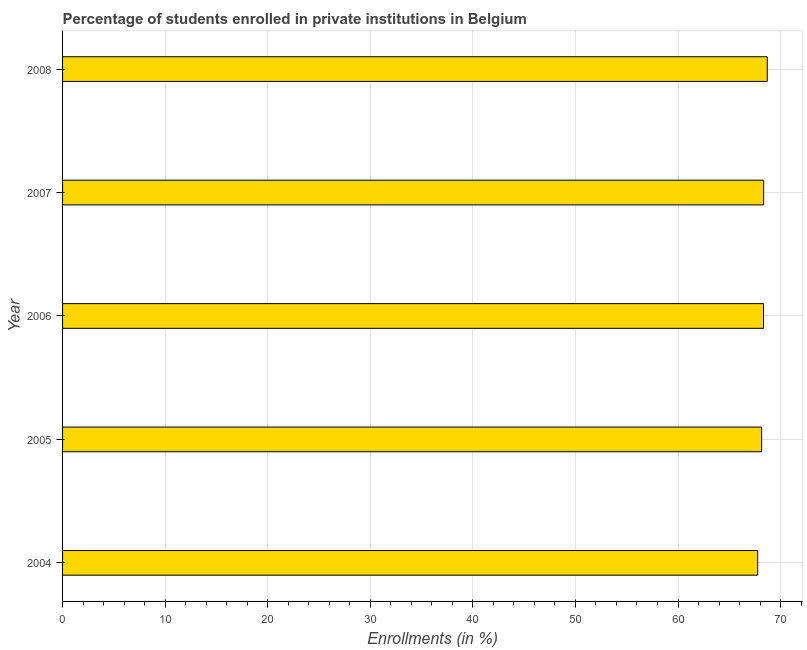Does the graph contain any zero values?
Make the answer very short. No. What is the title of the graph?
Make the answer very short. Percentage of students enrolled in private institutions in Belgium. What is the label or title of the X-axis?
Provide a short and direct response. Enrollments (in %). What is the label or title of the Y-axis?
Provide a succinct answer. Year. What is the enrollments in private institutions in 2004?
Offer a very short reply. 67.77. Across all years, what is the maximum enrollments in private institutions?
Your response must be concise. 68.7. Across all years, what is the minimum enrollments in private institutions?
Offer a terse response. 67.77. In which year was the enrollments in private institutions maximum?
Provide a short and direct response. 2008. What is the sum of the enrollments in private institutions?
Provide a short and direct response. 341.3. What is the difference between the enrollments in private institutions in 2004 and 2007?
Your answer should be very brief. -0.58. What is the average enrollments in private institutions per year?
Give a very brief answer. 68.26. What is the median enrollments in private institutions?
Ensure brevity in your answer.  68.33. Do a majority of the years between 2008 and 2006 (inclusive) have enrollments in private institutions greater than 52 %?
Keep it short and to the point. Yes. What is the difference between the highest and the second highest enrollments in private institutions?
Offer a very short reply. 0.35. Is the sum of the enrollments in private institutions in 2004 and 2006 greater than the maximum enrollments in private institutions across all years?
Provide a succinct answer. Yes. How many years are there in the graph?
Ensure brevity in your answer.  5. What is the Enrollments (in %) in 2004?
Offer a terse response. 67.77. What is the Enrollments (in %) in 2005?
Keep it short and to the point. 68.15. What is the Enrollments (in %) in 2006?
Give a very brief answer. 68.33. What is the Enrollments (in %) of 2007?
Make the answer very short. 68.35. What is the Enrollments (in %) in 2008?
Provide a short and direct response. 68.7. What is the difference between the Enrollments (in %) in 2004 and 2005?
Provide a short and direct response. -0.39. What is the difference between the Enrollments (in %) in 2004 and 2006?
Provide a short and direct response. -0.57. What is the difference between the Enrollments (in %) in 2004 and 2007?
Your response must be concise. -0.58. What is the difference between the Enrollments (in %) in 2004 and 2008?
Provide a succinct answer. -0.93. What is the difference between the Enrollments (in %) in 2005 and 2006?
Make the answer very short. -0.18. What is the difference between the Enrollments (in %) in 2005 and 2007?
Offer a terse response. -0.2. What is the difference between the Enrollments (in %) in 2005 and 2008?
Give a very brief answer. -0.55. What is the difference between the Enrollments (in %) in 2006 and 2007?
Offer a terse response. -0.01. What is the difference between the Enrollments (in %) in 2006 and 2008?
Your answer should be very brief. -0.37. What is the difference between the Enrollments (in %) in 2007 and 2008?
Ensure brevity in your answer.  -0.35. What is the ratio of the Enrollments (in %) in 2004 to that in 2007?
Provide a short and direct response. 0.99. What is the ratio of the Enrollments (in %) in 2004 to that in 2008?
Your answer should be compact. 0.99. What is the ratio of the Enrollments (in %) in 2005 to that in 2007?
Provide a short and direct response. 1. What is the ratio of the Enrollments (in %) in 2005 to that in 2008?
Ensure brevity in your answer.  0.99. What is the ratio of the Enrollments (in %) in 2006 to that in 2007?
Provide a succinct answer. 1. What is the ratio of the Enrollments (in %) in 2006 to that in 2008?
Your answer should be compact. 0.99. 